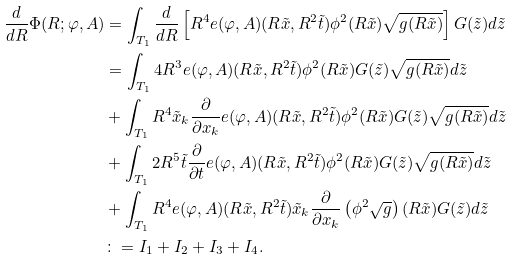<formula> <loc_0><loc_0><loc_500><loc_500>\frac { d } { d R } \Phi ( R ; \varphi , A ) & = \int _ { T _ { 1 } } { \frac { d } { d R } \left [ { R ^ { 4 } e ( \varphi , A ) ( R \tilde { x } , R ^ { 2 } \tilde { t } ) \phi ^ { 2 } ( R \tilde { x } ) \sqrt { g ( R \tilde { x } ) } } \right ] G ( \tilde { z } ) d \tilde { z } } \\ & = \int _ { T _ { 1 } } { 4 R ^ { 3 } e ( \varphi , A ) ( R \tilde { x } , R ^ { 2 } \tilde { t } ) \phi ^ { 2 } ( R \tilde { x } ) G ( \tilde { z } ) \sqrt { g ( R \tilde { x } ) } d \tilde { z } } \\ & + \int _ { T _ { 1 } } { R ^ { 4 } \tilde { x } _ { k } \frac { \partial } { \partial x _ { k } } e ( \varphi , A ) ( R \tilde { x } , R ^ { 2 } \tilde { t } ) \phi ^ { 2 } ( R \tilde { x } ) G ( \tilde { z } ) \sqrt { g ( R \tilde { x } ) } d \tilde { z } } \\ & + \int _ { T _ { 1 } } { 2 R ^ { 5 } \tilde { t } \frac { \partial } { \partial t } e ( \varphi , A ) ( R \tilde { x } , R ^ { 2 } \tilde { t } ) \phi ^ { 2 } ( R \tilde { x } ) G ( \tilde { z } ) \sqrt { g ( R \tilde { x } ) } d \tilde { z } } \\ & + \int _ { T _ { 1 } } { R ^ { 4 } e ( \varphi , A ) ( R \tilde { x } , R ^ { 2 } \tilde { t } ) \tilde { x } _ { k } \frac { \partial } { \partial x _ { k } } \left ( { \phi ^ { 2 } \sqrt { g } } \right ) ( R \tilde { x } ) G ( \tilde { z } ) d \tilde { z } } \\ & \colon = I _ { 1 } + I _ { 2 } + I _ { 3 } + I _ { 4 } .</formula> 